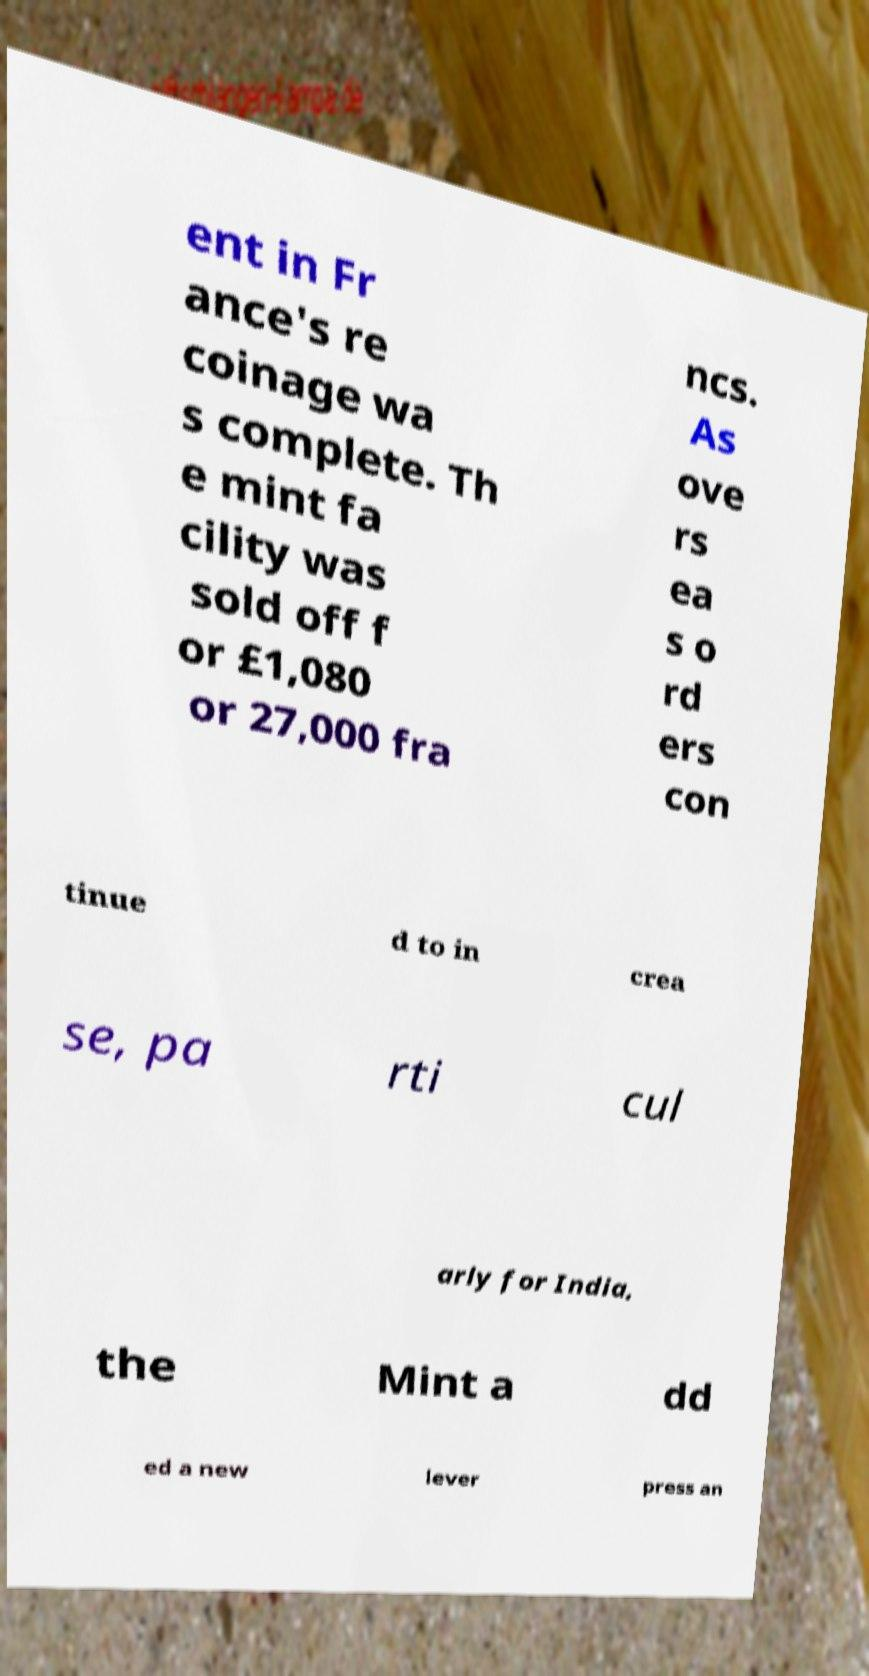Can you accurately transcribe the text from the provided image for me? ent in Fr ance's re coinage wa s complete. Th e mint fa cility was sold off f or £1,080 or 27,000 fra ncs. As ove rs ea s o rd ers con tinue d to in crea se, pa rti cul arly for India, the Mint a dd ed a new lever press an 